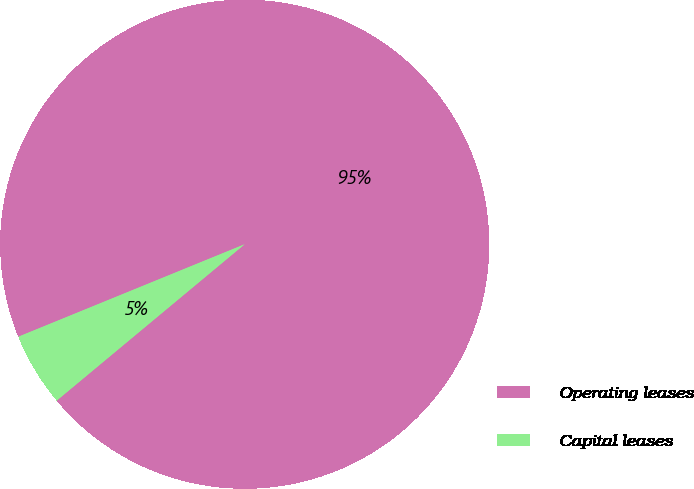Convert chart. <chart><loc_0><loc_0><loc_500><loc_500><pie_chart><fcel>Operating leases<fcel>Capital leases<nl><fcel>95.13%<fcel>4.87%<nl></chart> 